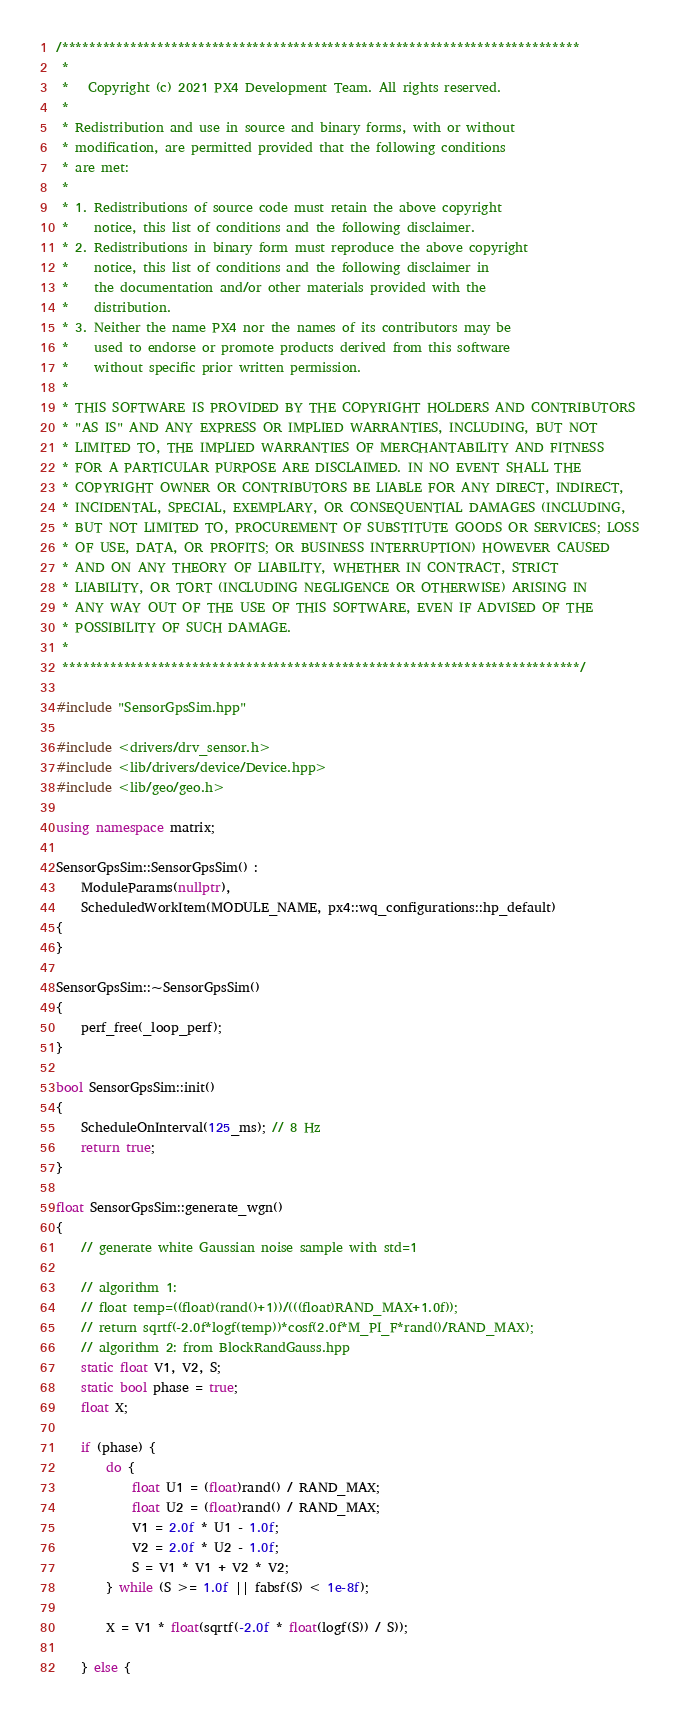<code> <loc_0><loc_0><loc_500><loc_500><_C++_>/****************************************************************************
 *
 *   Copyright (c) 2021 PX4 Development Team. All rights reserved.
 *
 * Redistribution and use in source and binary forms, with or without
 * modification, are permitted provided that the following conditions
 * are met:
 *
 * 1. Redistributions of source code must retain the above copyright
 *    notice, this list of conditions and the following disclaimer.
 * 2. Redistributions in binary form must reproduce the above copyright
 *    notice, this list of conditions and the following disclaimer in
 *    the documentation and/or other materials provided with the
 *    distribution.
 * 3. Neither the name PX4 nor the names of its contributors may be
 *    used to endorse or promote products derived from this software
 *    without specific prior written permission.
 *
 * THIS SOFTWARE IS PROVIDED BY THE COPYRIGHT HOLDERS AND CONTRIBUTORS
 * "AS IS" AND ANY EXPRESS OR IMPLIED WARRANTIES, INCLUDING, BUT NOT
 * LIMITED TO, THE IMPLIED WARRANTIES OF MERCHANTABILITY AND FITNESS
 * FOR A PARTICULAR PURPOSE ARE DISCLAIMED. IN NO EVENT SHALL THE
 * COPYRIGHT OWNER OR CONTRIBUTORS BE LIABLE FOR ANY DIRECT, INDIRECT,
 * INCIDENTAL, SPECIAL, EXEMPLARY, OR CONSEQUENTIAL DAMAGES (INCLUDING,
 * BUT NOT LIMITED TO, PROCUREMENT OF SUBSTITUTE GOODS OR SERVICES; LOSS
 * OF USE, DATA, OR PROFITS; OR BUSINESS INTERRUPTION) HOWEVER CAUSED
 * AND ON ANY THEORY OF LIABILITY, WHETHER IN CONTRACT, STRICT
 * LIABILITY, OR TORT (INCLUDING NEGLIGENCE OR OTHERWISE) ARISING IN
 * ANY WAY OUT OF THE USE OF THIS SOFTWARE, EVEN IF ADVISED OF THE
 * POSSIBILITY OF SUCH DAMAGE.
 *
 ****************************************************************************/

#include "SensorGpsSim.hpp"

#include <drivers/drv_sensor.h>
#include <lib/drivers/device/Device.hpp>
#include <lib/geo/geo.h>

using namespace matrix;

SensorGpsSim::SensorGpsSim() :
	ModuleParams(nullptr),
	ScheduledWorkItem(MODULE_NAME, px4::wq_configurations::hp_default)
{
}

SensorGpsSim::~SensorGpsSim()
{
	perf_free(_loop_perf);
}

bool SensorGpsSim::init()
{
	ScheduleOnInterval(125_ms); // 8 Hz
	return true;
}

float SensorGpsSim::generate_wgn()
{
	// generate white Gaussian noise sample with std=1

	// algorithm 1:
	// float temp=((float)(rand()+1))/(((float)RAND_MAX+1.0f));
	// return sqrtf(-2.0f*logf(temp))*cosf(2.0f*M_PI_F*rand()/RAND_MAX);
	// algorithm 2: from BlockRandGauss.hpp
	static float V1, V2, S;
	static bool phase = true;
	float X;

	if (phase) {
		do {
			float U1 = (float)rand() / RAND_MAX;
			float U2 = (float)rand() / RAND_MAX;
			V1 = 2.0f * U1 - 1.0f;
			V2 = 2.0f * U2 - 1.0f;
			S = V1 * V1 + V2 * V2;
		} while (S >= 1.0f || fabsf(S) < 1e-8f);

		X = V1 * float(sqrtf(-2.0f * float(logf(S)) / S));

	} else {</code> 